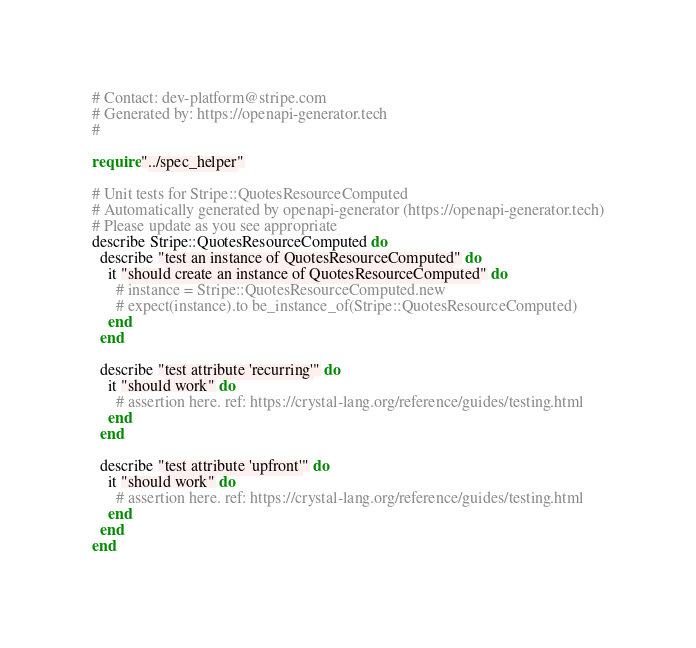Convert code to text. <code><loc_0><loc_0><loc_500><loc_500><_Crystal_># Contact: dev-platform@stripe.com
# Generated by: https://openapi-generator.tech
#

require "../spec_helper"

# Unit tests for Stripe::QuotesResourceComputed
# Automatically generated by openapi-generator (https://openapi-generator.tech)
# Please update as you see appropriate
describe Stripe::QuotesResourceComputed do
  describe "test an instance of QuotesResourceComputed" do
    it "should create an instance of QuotesResourceComputed" do
      # instance = Stripe::QuotesResourceComputed.new
      # expect(instance).to be_instance_of(Stripe::QuotesResourceComputed)
    end
  end

  describe "test attribute 'recurring'" do
    it "should work" do
      # assertion here. ref: https://crystal-lang.org/reference/guides/testing.html
    end
  end

  describe "test attribute 'upfront'" do
    it "should work" do
      # assertion here. ref: https://crystal-lang.org/reference/guides/testing.html
    end
  end
end
</code> 